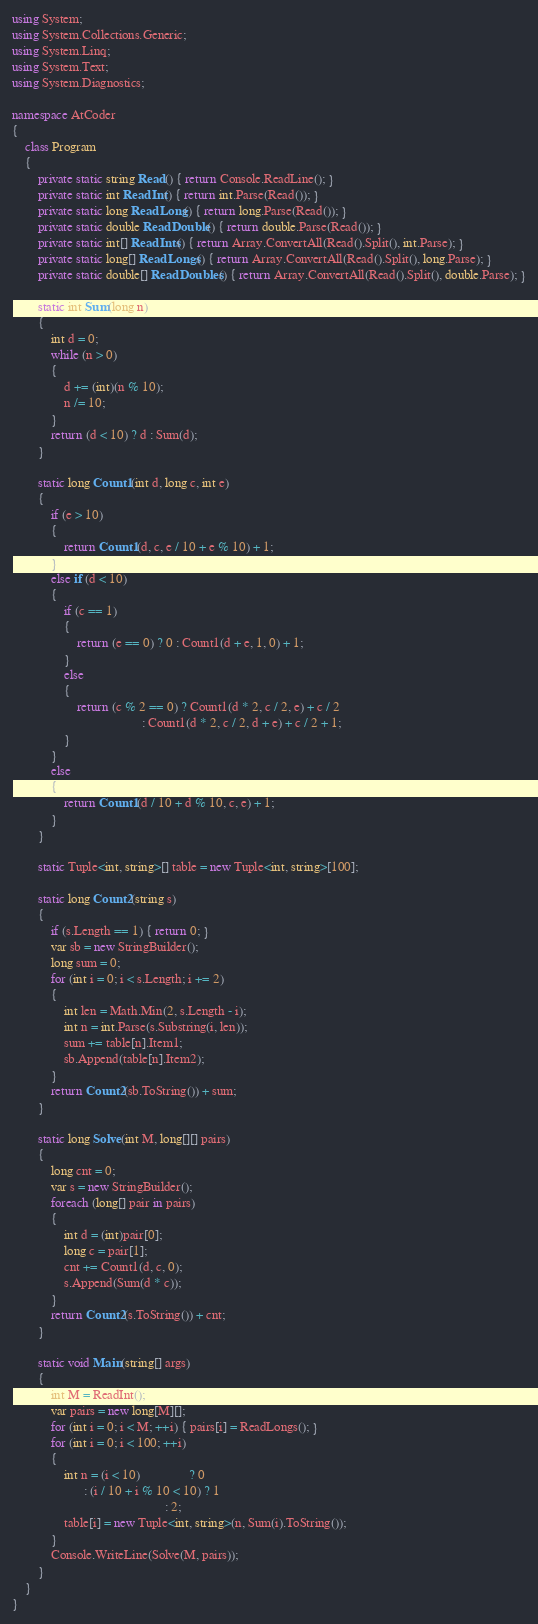<code> <loc_0><loc_0><loc_500><loc_500><_C#_>using System;
using System.Collections.Generic;
using System.Linq;
using System.Text;
using System.Diagnostics;

namespace AtCoder
{
    class Program
    {
        private static string Read() { return Console.ReadLine(); }
        private static int ReadInt() { return int.Parse(Read()); }
        private static long ReadLong() { return long.Parse(Read()); }
        private static double ReadDouble() { return double.Parse(Read()); }
        private static int[] ReadInts() { return Array.ConvertAll(Read().Split(), int.Parse); }
        private static long[] ReadLongs() { return Array.ConvertAll(Read().Split(), long.Parse); }
        private static double[] ReadDoubles() { return Array.ConvertAll(Read().Split(), double.Parse); }

        static int Sum(long n)
        {
            int d = 0;
            while (n > 0)
            {
                d += (int)(n % 10);
                n /= 10;
            }
            return (d < 10) ? d : Sum(d);
        }

        static long Count1(int d, long c, int e)
        {
            if (e > 10)
            {
                return Count1(d, c, e / 10 + e % 10) + 1;
            }
            else if (d < 10)
            {
                if (c == 1)
                {
                    return (e == 0) ? 0 : Count1(d + e, 1, 0) + 1;
                }
                else
                {
                    return (c % 2 == 0) ? Count1(d * 2, c / 2, e) + c / 2
                                        : Count1(d * 2, c / 2, d + e) + c / 2 + 1;
                }
            }
            else
            {
                return Count1(d / 10 + d % 10, c, e) + 1;
            }
        }

        static Tuple<int, string>[] table = new Tuple<int, string>[100];

        static long Count2(string s)
        {
            if (s.Length == 1) { return 0; }
            var sb = new StringBuilder();
            long sum = 0;
            for (int i = 0; i < s.Length; i += 2)
            {
                int len = Math.Min(2, s.Length - i);
                int n = int.Parse(s.Substring(i, len));
                sum += table[n].Item1;
                sb.Append(table[n].Item2);
            }
            return Count2(sb.ToString()) + sum;
        }

        static long Solve(int M, long[][] pairs)
        {
            long cnt = 0;
            var s = new StringBuilder();
            foreach (long[] pair in pairs)
            {
                int d = (int)pair[0];
                long c = pair[1];
                cnt += Count1(d, c, 0);
                s.Append(Sum(d * c));
            }
            return Count2(s.ToString()) + cnt;
        }

        static void Main(string[] args)
        {
            int M = ReadInt();
            var pairs = new long[M][];
            for (int i = 0; i < M; ++i) { pairs[i] = ReadLongs(); }
            for (int i = 0; i < 100; ++i)
            {
                int n = (i < 10)               ? 0
                      : (i / 10 + i % 10 < 10) ? 1
                                               : 2;
                table[i] = new Tuple<int, string>(n, Sum(i).ToString());
            }
            Console.WriteLine(Solve(M, pairs));
        }
    }
}
</code> 